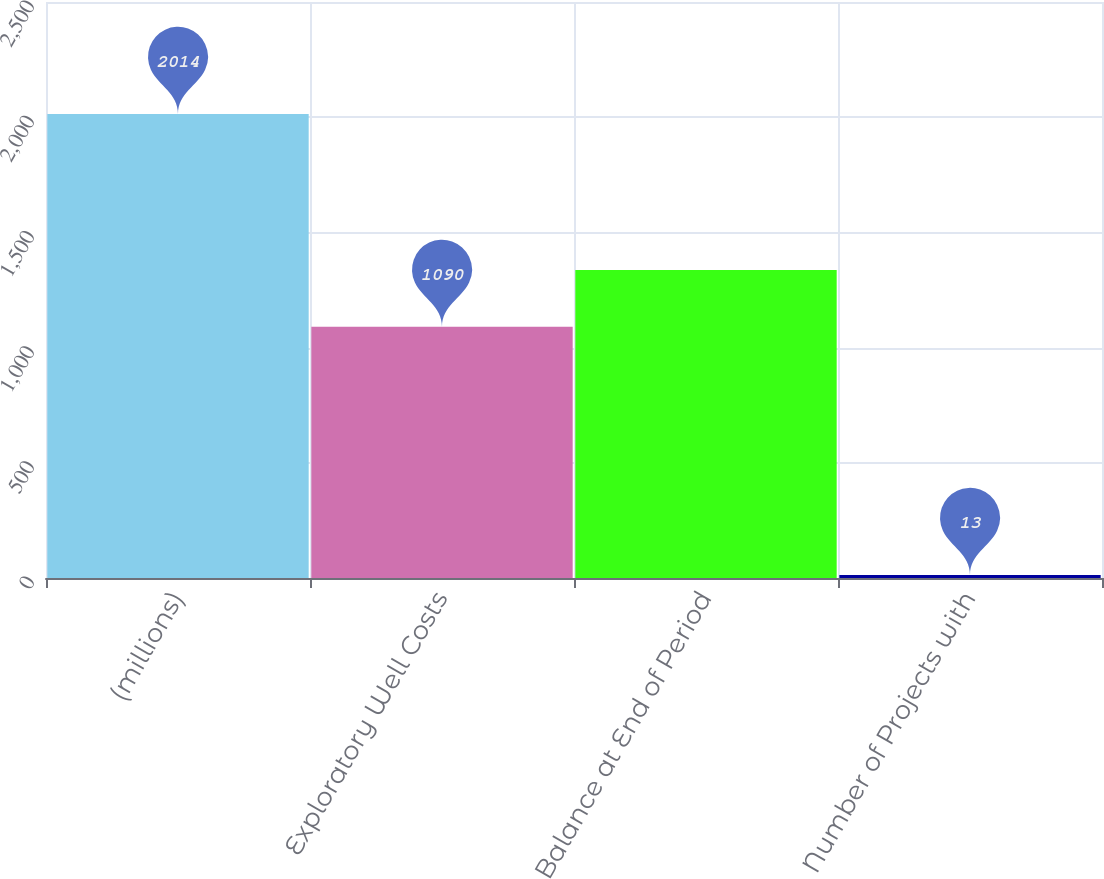Convert chart to OTSL. <chart><loc_0><loc_0><loc_500><loc_500><bar_chart><fcel>(millions)<fcel>Exploratory Well Costs<fcel>Balance at End of Period<fcel>Number of Projects with<nl><fcel>2014<fcel>1090<fcel>1337<fcel>13<nl></chart> 